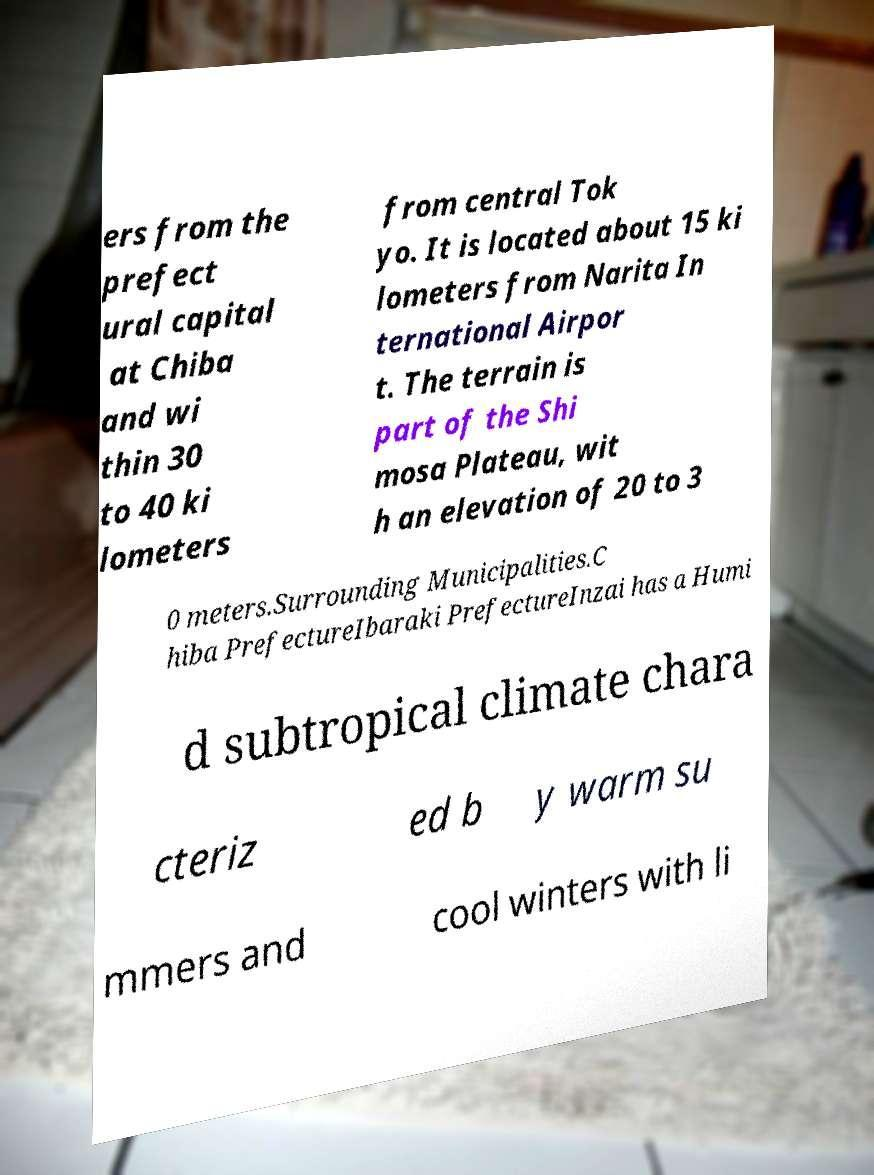Can you accurately transcribe the text from the provided image for me? ers from the prefect ural capital at Chiba and wi thin 30 to 40 ki lometers from central Tok yo. It is located about 15 ki lometers from Narita In ternational Airpor t. The terrain is part of the Shi mosa Plateau, wit h an elevation of 20 to 3 0 meters.Surrounding Municipalities.C hiba PrefectureIbaraki PrefectureInzai has a Humi d subtropical climate chara cteriz ed b y warm su mmers and cool winters with li 